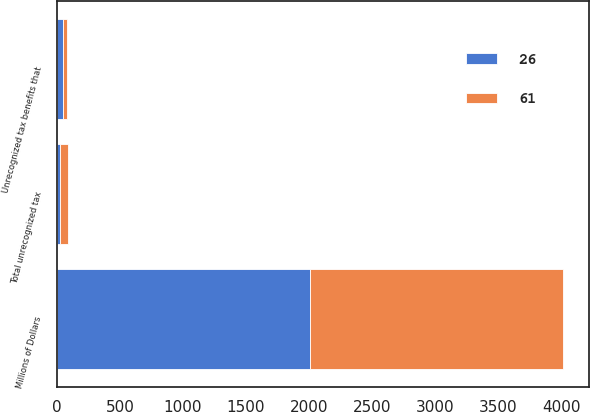<chart> <loc_0><loc_0><loc_500><loc_500><stacked_bar_chart><ecel><fcel>Millions of Dollars<fcel>Unrecognized tax benefits that<fcel>Total unrecognized tax<nl><fcel>61<fcel>2009<fcel>25<fcel>61<nl><fcel>26<fcel>2008<fcel>53<fcel>26<nl></chart> 